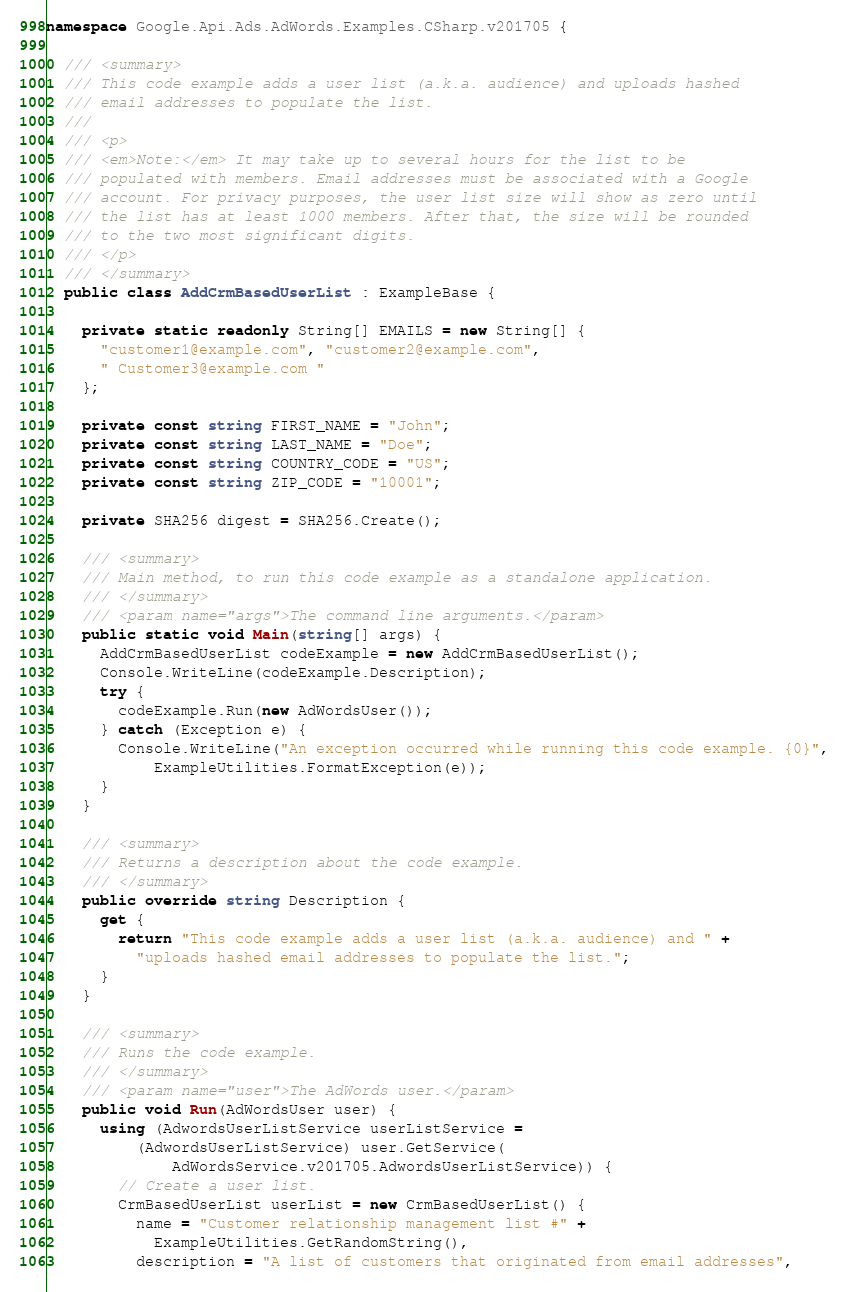Convert code to text. <code><loc_0><loc_0><loc_500><loc_500><_C#_>
namespace Google.Api.Ads.AdWords.Examples.CSharp.v201705 {

  /// <summary>
  /// This code example adds a user list (a.k.a. audience) and uploads hashed
  /// email addresses to populate the list.
  ///
  /// <p>
  /// <em>Note:</em> It may take up to several hours for the list to be
  /// populated with members. Email addresses must be associated with a Google
  /// account. For privacy purposes, the user list size will show as zero until
  /// the list has at least 1000 members. After that, the size will be rounded
  /// to the two most significant digits.
  /// </p>
  /// </summary>
  public class AddCrmBasedUserList : ExampleBase {

    private static readonly String[] EMAILS = new String[] {
      "customer1@example.com", "customer2@example.com",
      " Customer3@example.com "
    };

    private const string FIRST_NAME = "John";
    private const string LAST_NAME = "Doe";
    private const string COUNTRY_CODE = "US";
    private const string ZIP_CODE = "10001";

    private SHA256 digest = SHA256.Create();

    /// <summary>
    /// Main method, to run this code example as a standalone application.
    /// </summary>
    /// <param name="args">The command line arguments.</param>
    public static void Main(string[] args) {
      AddCrmBasedUserList codeExample = new AddCrmBasedUserList();
      Console.WriteLine(codeExample.Description);
      try {
        codeExample.Run(new AdWordsUser());
      } catch (Exception e) {
        Console.WriteLine("An exception occurred while running this code example. {0}",
            ExampleUtilities.FormatException(e));
      }
    }

    /// <summary>
    /// Returns a description about the code example.
    /// </summary>
    public override string Description {
      get {
        return "This code example adds a user list (a.k.a. audience) and " +
          "uploads hashed email addresses to populate the list.";
      }
    }

    /// <summary>
    /// Runs the code example.
    /// </summary>
    /// <param name="user">The AdWords user.</param>
    public void Run(AdWordsUser user) {
      using (AdwordsUserListService userListService =
          (AdwordsUserListService) user.GetService(
              AdWordsService.v201705.AdwordsUserListService)) {
        // Create a user list.
        CrmBasedUserList userList = new CrmBasedUserList() {
          name = "Customer relationship management list #" +
            ExampleUtilities.GetRandomString(),
          description = "A list of customers that originated from email addresses",
</code> 